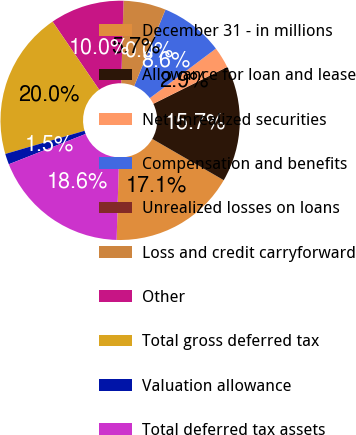<chart> <loc_0><loc_0><loc_500><loc_500><pie_chart><fcel>December 31 - in millions<fcel>Allowance for loan and lease<fcel>Net unrealized securities<fcel>Compensation and benefits<fcel>Unrealized losses on loans<fcel>Loss and credit carryforward<fcel>Other<fcel>Total gross deferred tax<fcel>Valuation allowance<fcel>Total deferred tax assets<nl><fcel>17.13%<fcel>15.7%<fcel>2.87%<fcel>8.57%<fcel>0.02%<fcel>5.72%<fcel>10.0%<fcel>19.98%<fcel>1.45%<fcel>18.55%<nl></chart> 